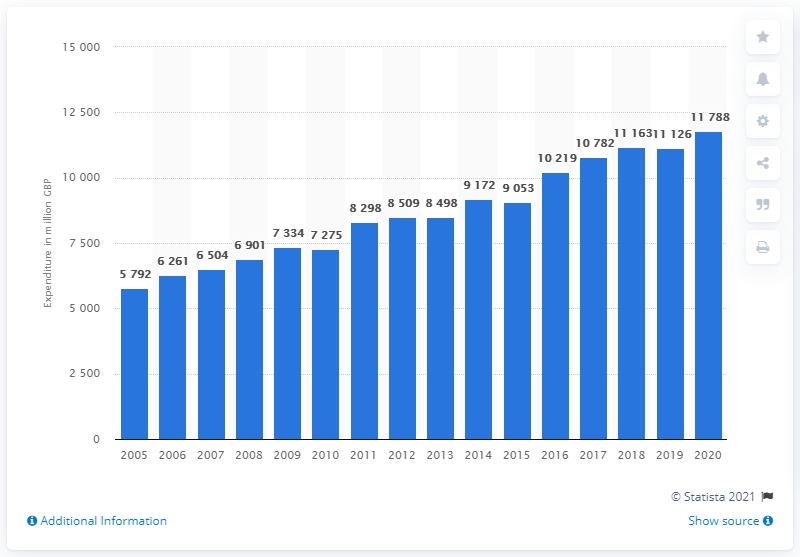Specify some key components in this picture. In 2020, the total amount of money spent by consumers in the UK on fruit was 11,788 million pounds. 